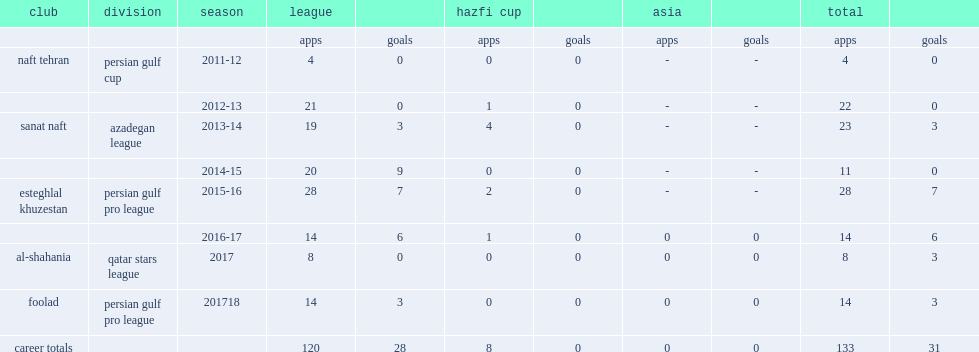Which club did rahim zahivi play for in 2015-16? Esteghlal khuzestan. Could you parse the entire table? {'header': ['club', 'division', 'season', 'league', '', 'hazfi cup', '', 'asia', '', 'total', ''], 'rows': [['', '', '', 'apps', 'goals', 'apps', 'goals', 'apps', 'goals', 'apps', 'goals'], ['naft tehran', 'persian gulf cup', '2011-12', '4', '0', '0', '0', '-', '-', '4', '0'], ['', '', '2012-13', '21', '0', '1', '0', '-', '-', '22', '0'], ['sanat naft', 'azadegan league', '2013-14', '19', '3', '4', '0', '-', '-', '23', '3'], ['', '', '2014-15', '20', '9', '0', '0', '-', '-', '11', '0'], ['esteghlal khuzestan', 'persian gulf pro league', '2015-16', '28', '7', '2', '0', '-', '-', '28', '7'], ['', '', '2016-17', '14', '6', '1', '0', '0', '0', '14', '6'], ['al-shahania', 'qatar stars league', '2017', '8', '0', '0', '0', '0', '0', '8', '3'], ['foolad', 'persian gulf pro league', '201718', '14', '3', '0', '0', '0', '0', '14', '3'], ['career totals', '', '', '120', '28', '8', '0', '0', '0', '133', '31']]} 